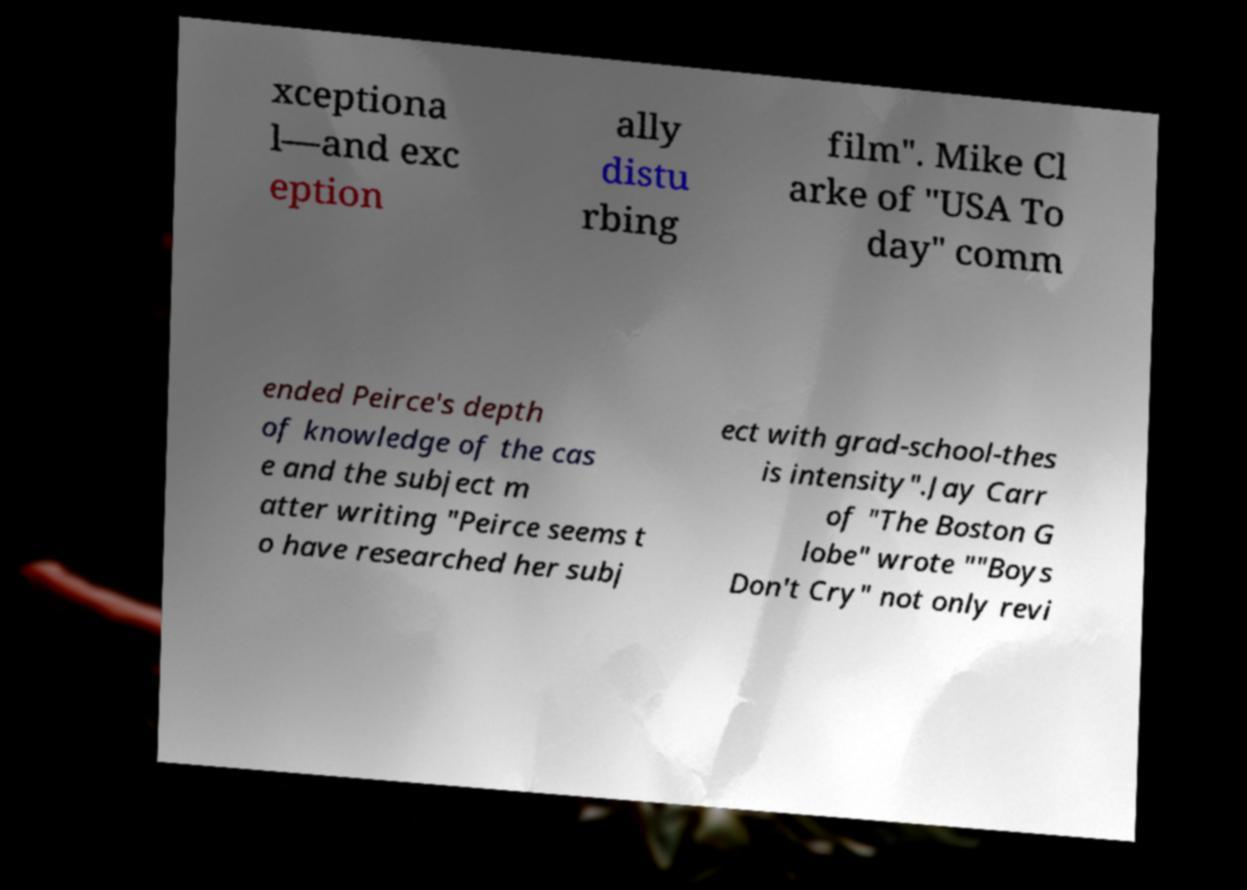Please read and relay the text visible in this image. What does it say? xceptiona l—and exc eption ally distu rbing film". Mike Cl arke of "USA To day" comm ended Peirce's depth of knowledge of the cas e and the subject m atter writing "Peirce seems t o have researched her subj ect with grad-school-thes is intensity".Jay Carr of "The Boston G lobe" wrote ""Boys Don't Cry" not only revi 